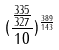Convert formula to latex. <formula><loc_0><loc_0><loc_500><loc_500>( \frac { \frac { 3 3 5 } { 3 2 7 } } { 1 0 } ) ^ { \frac { 3 8 9 } { 1 4 3 } }</formula> 